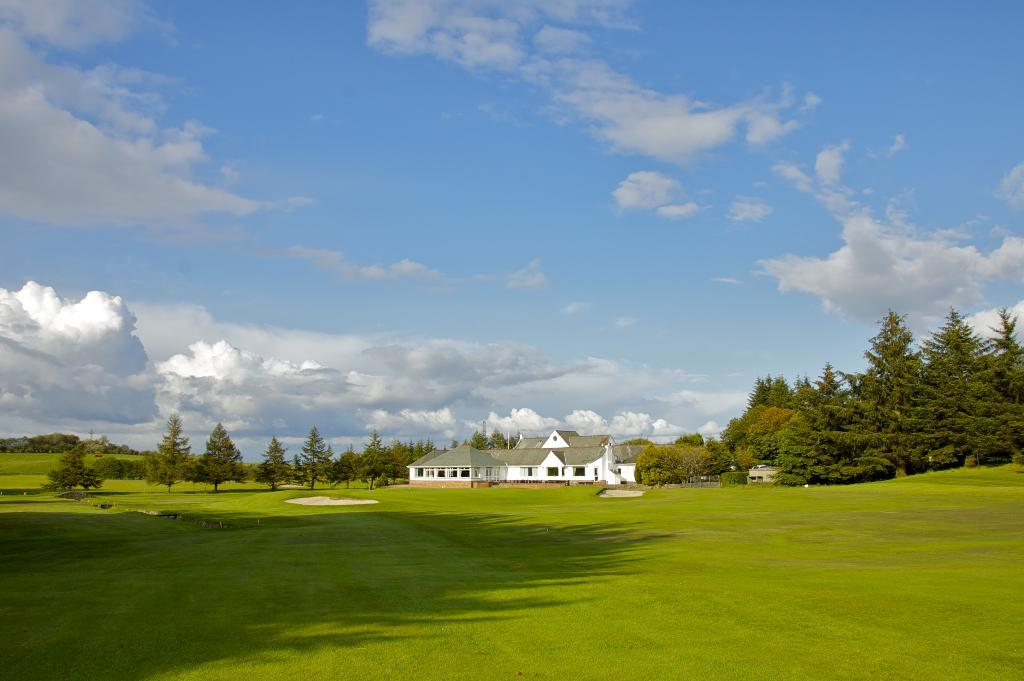What type of vegetation is present at the bottom of the image? There is grass on the ground at the bottom of the image. What can be seen in the background of the image? There are trees and houses in the background of the image. What is visible in the sky in the background of the image? There are clouds in the sky in the background of the image. What is the condition of the railway in the image? There is no railway present in the image. 